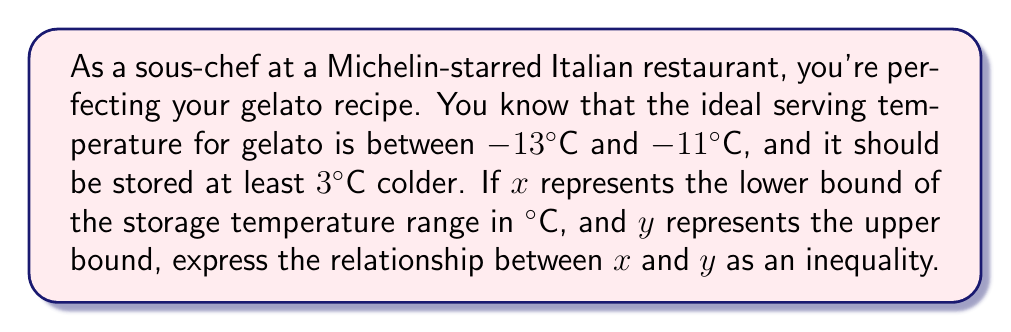Help me with this question. Let's approach this step-by-step:

1) First, we know that the ideal serving temperature is between -13°C and -11°C.

2) The storage temperature should be at least 3°C colder than the serving temperature.

3) For the lower bound $x$:
   It should be at least 3°C colder than the lowest serving temperature (-13°C).
   $x \leq -13 - 3 = -16$

4) For the upper bound $y$:
   It should be at least 3°C colder than the highest serving temperature (-11°C).
   $y \leq -11 - 3 = -14$

5) We also know that $x$ is the lower bound and $y$ is the upper bound, so:
   $x < y$

6) Combining these inequalities, we get:
   $-16 \leq x < y \leq -14$

This inequality represents the relationship between the lower and upper bounds of the storage temperature range for perfect gelato consistency.
Answer: $-16 \leq x < y \leq -14$ 